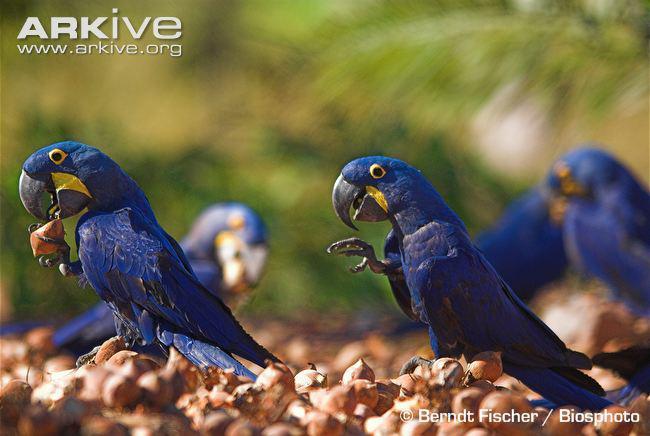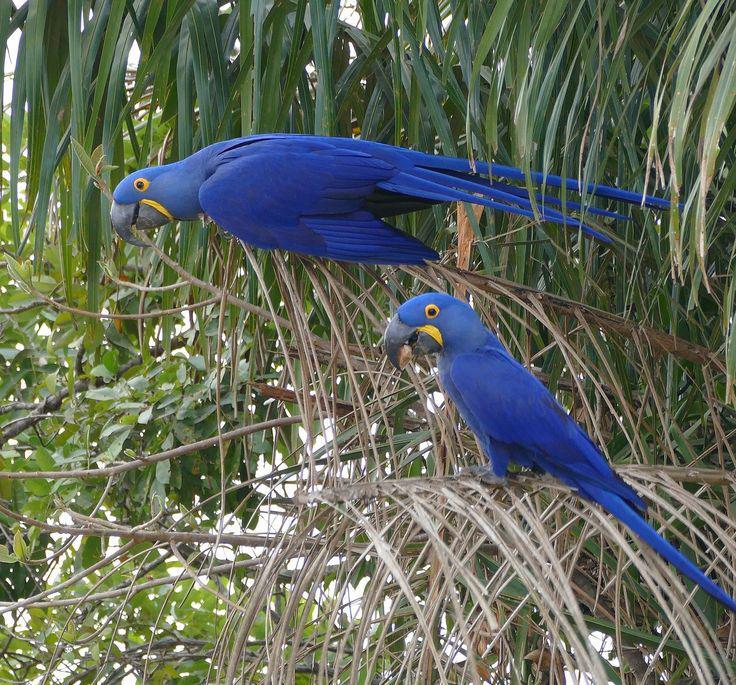The first image is the image on the left, the second image is the image on the right. Evaluate the accuracy of this statement regarding the images: "There are several parrots, definitely more than two.". Is it true? Answer yes or no. Yes. The first image is the image on the left, the second image is the image on the right. For the images displayed, is the sentence "There are at most two birds." factually correct? Answer yes or no. No. 